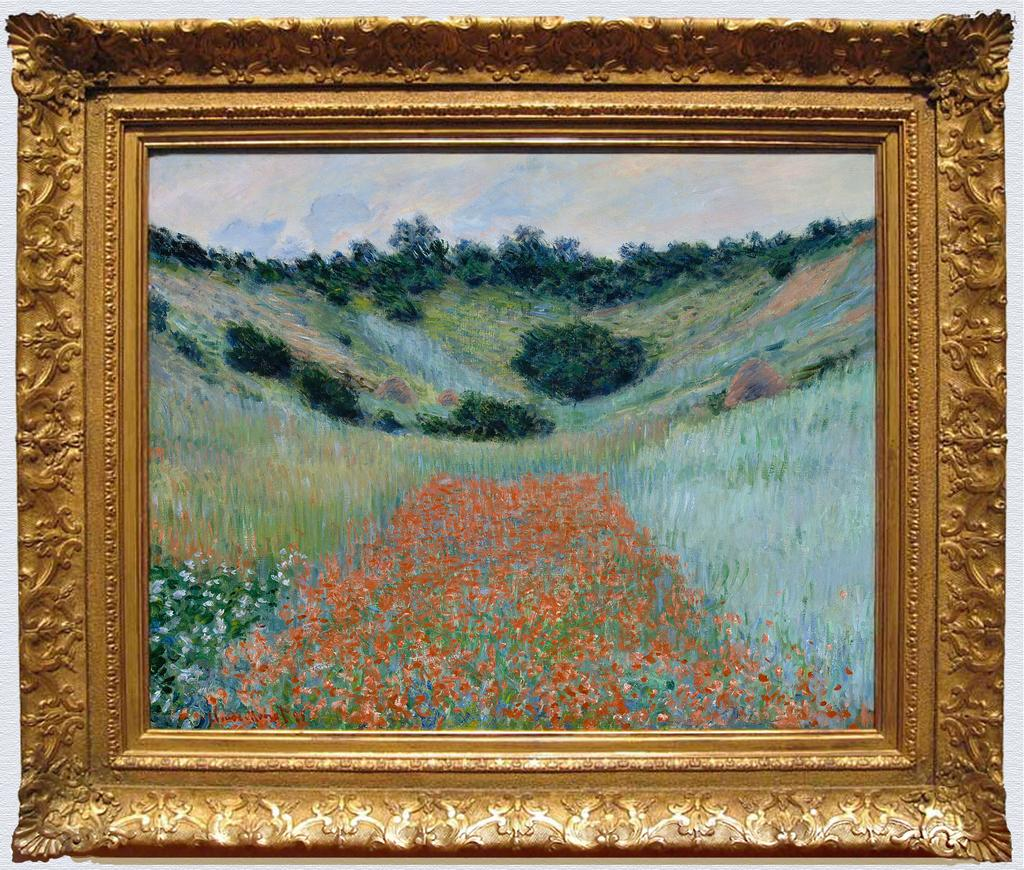What is hanging on the wall in the image? There is a photo frame on the wall in the image. What is depicted in the photo frame? The photo frame contains a picture of flowering plants, a picture of a farm field, and a picture of trees. Can you describe the content of the pictures in the photo frame? The photo frame contains pictures of flowering plants, a farm field, and trees. Where is the snail hiding in the image? There is no snail present in the image. What type of tank is visible in the image? There is no tank present in the image. 